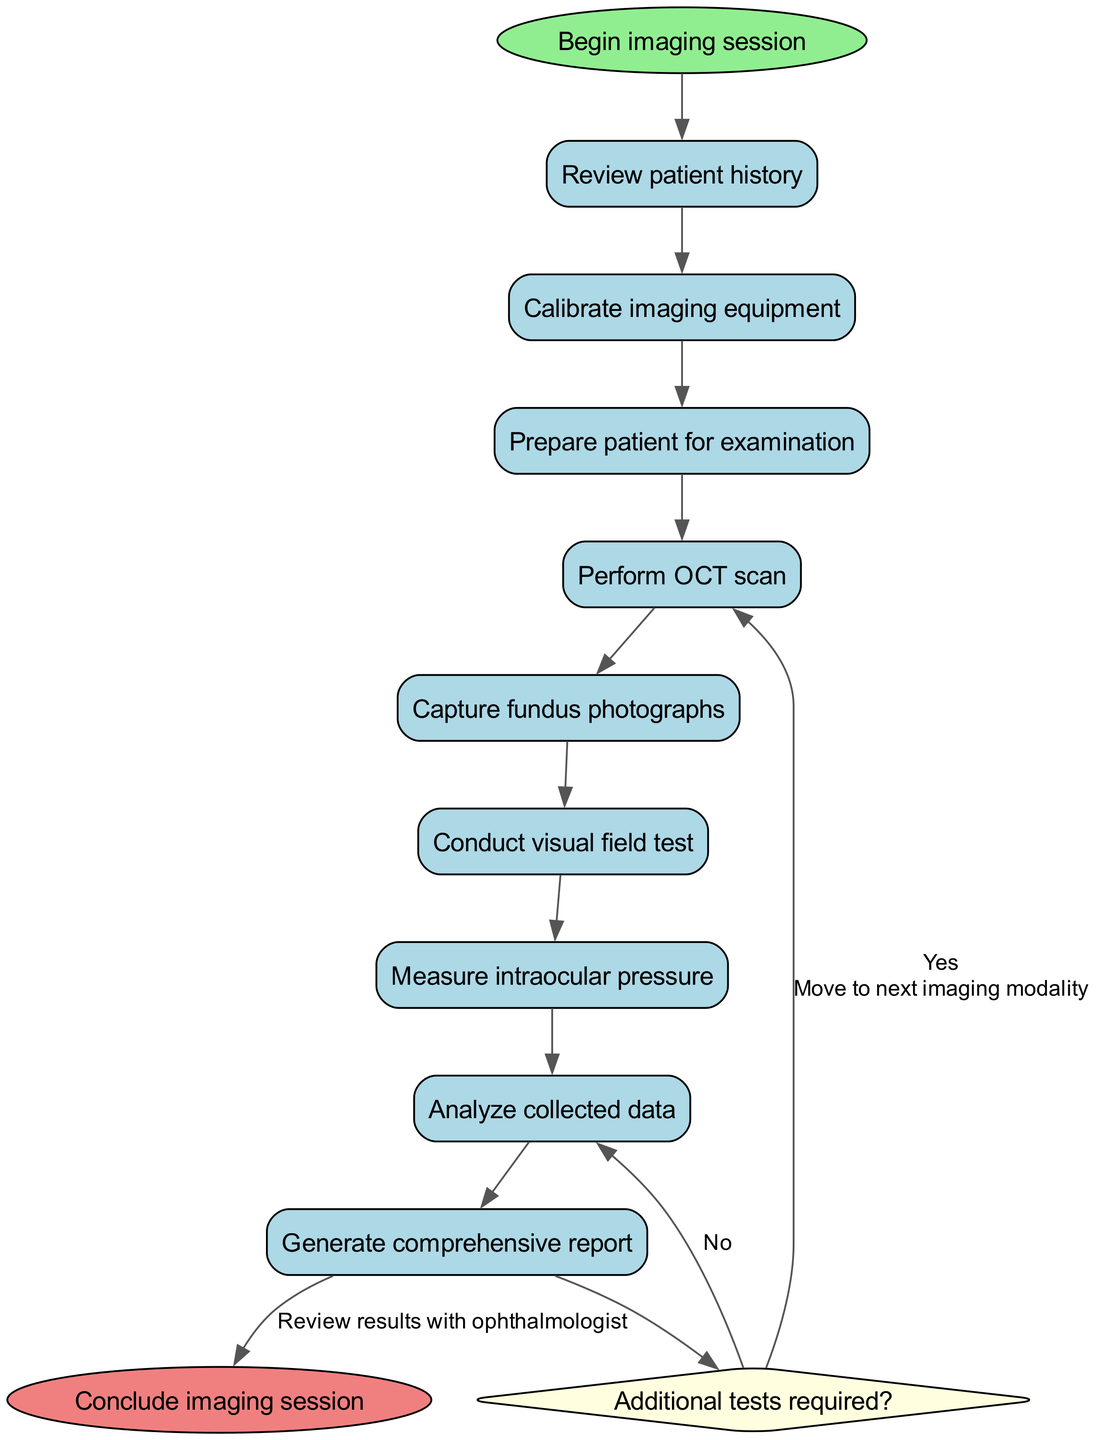What is the first activity in the workflow? The first activity in the workflow is designated as "activity_0" in the diagram, which corresponds to "Review patient history."
Answer: Review patient history How many activities are included in the workflow? The diagram lists a total of eight activities included in the "activities" section. Counting each activity from "Review patient history" to "Generate comprehensive report" confirms this.
Answer: 8 What happens if additional tests are required? According to the decision node in the diagram, if additional tests are required, the workflow proceeds to "Perform additional tests" as indicated by the 'Yes' edge from the decision node.
Answer: Perform additional tests What is the last step in the imaging session workflow? The last step of the workflow is defined as "Conclude imaging session," which is connected to the "Generate comprehensive report" activity through the edges in the diagram.
Answer: Conclude imaging session What is the edge leading from the decision node to the data analysis activity labeled as? The edge that leads from the decision node to the data analysis activity is labeled "No," indicating that if additional tests are not required, the workflow proceeds to "Analyze collected data."
Answer: No How many edges are connecting the nodes in the diagram? Each activity is connected by edges, along with the decision and end nodes. Counting all connections, including from the start node through the decision node and finally to the end, gives a total of ten edges.
Answer: 10 Which activity directly follows the "Capture fundus photographs" in the workflow? The diagram shows that the activity that directly follows "Capture fundus photographs" is "Conduct visual field test," as per the sequential connections represented in the diagram.
Answer: Conduct visual field test What does the "edge" labelled 'Move to next imaging modality' connect to? The edge labelled 'Move to next imaging modality' connects the decision node back to the "Perform OCT scan" activity, indicating a loop for conducting more tests.
Answer: Perform OCT scan 